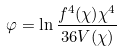Convert formula to latex. <formula><loc_0><loc_0><loc_500><loc_500>\varphi = \ln \frac { f ^ { 4 } ( \chi ) \chi ^ { 4 } } { 3 6 V ( \chi ) }</formula> 